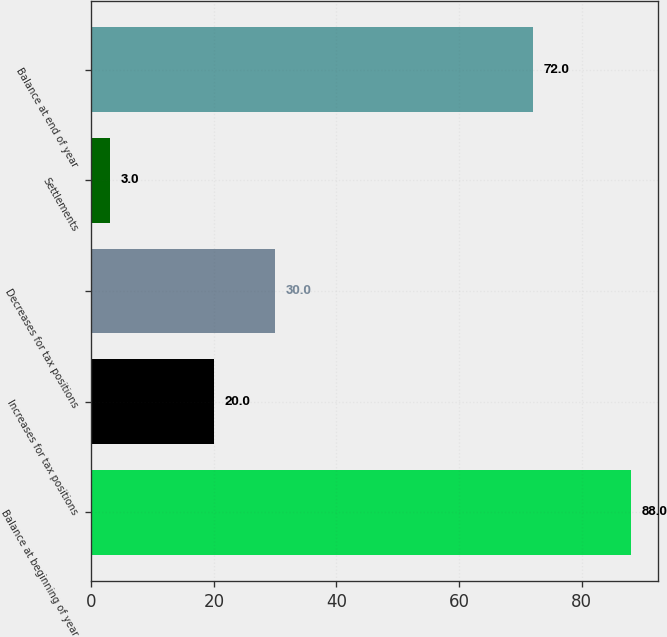Convert chart to OTSL. <chart><loc_0><loc_0><loc_500><loc_500><bar_chart><fcel>Balance at beginning of year<fcel>Increases for tax positions<fcel>Decreases for tax positions<fcel>Settlements<fcel>Balance at end of year<nl><fcel>88<fcel>20<fcel>30<fcel>3<fcel>72<nl></chart> 